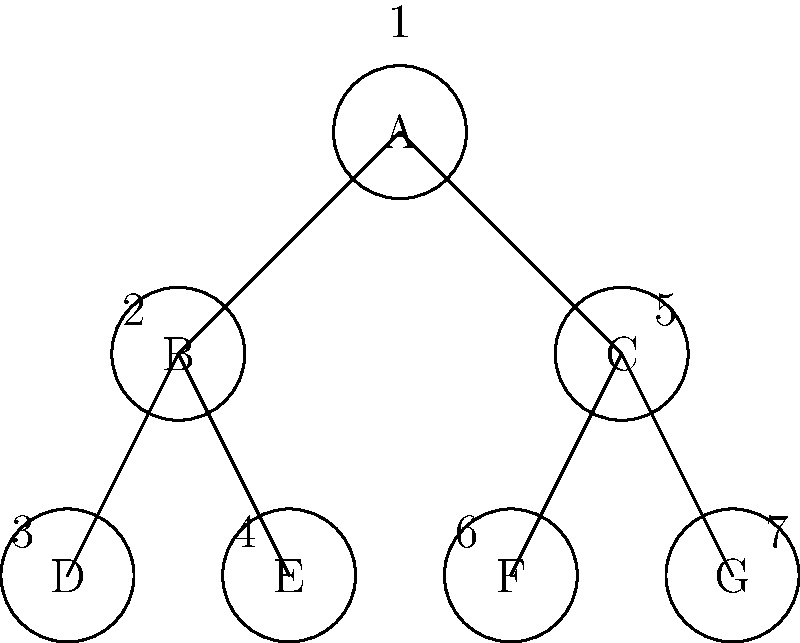Given the binary tree above with nodes labeled A through G, what is the correct order of node visits for an in-order traversal? Assume that the numbers next to the nodes indicate the order in which they were added to the tree. To perform an in-order traversal of a binary tree, we follow these steps for each node:
1. Recursively traverse the left subtree
2. Visit the current node
3. Recursively traverse the right subtree

Let's apply this to our tree:

1. Start at the root node A
2. Traverse left to node B
3. Traverse left to node D (leaf node)
4. Visit D
5. Move back to B
6. Visit B
7. Traverse right to E (leaf node)
8. Visit E
9. Move back to A
10. Visit A
11. Traverse right to C
12. Traverse left to F (leaf node)
13. Visit F
14. Move back to C
15. Visit C
16. Traverse right to G (leaf node)
17. Visit G

The order of node visits is therefore: D, B, E, A, F, C, G
Answer: D, B, E, A, F, C, G 